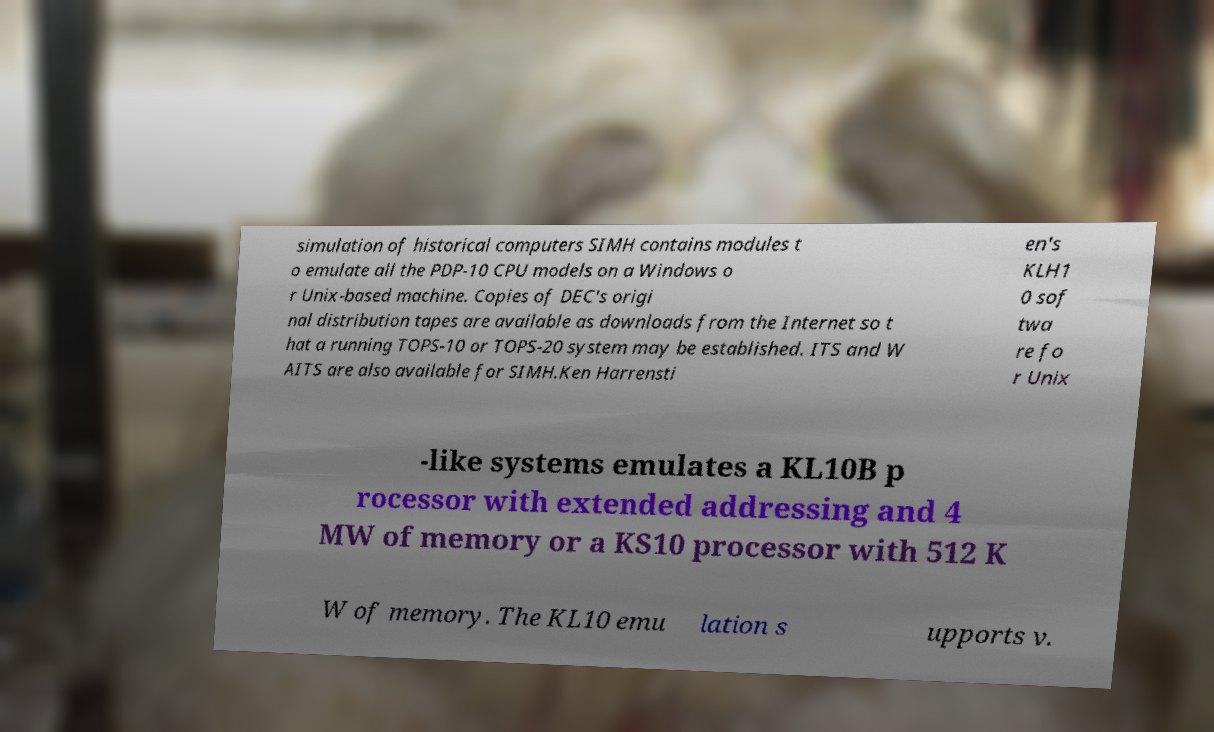Can you accurately transcribe the text from the provided image for me? simulation of historical computers SIMH contains modules t o emulate all the PDP-10 CPU models on a Windows o r Unix-based machine. Copies of DEC's origi nal distribution tapes are available as downloads from the Internet so t hat a running TOPS-10 or TOPS-20 system may be established. ITS and W AITS are also available for SIMH.Ken Harrensti en's KLH1 0 sof twa re fo r Unix -like systems emulates a KL10B p rocessor with extended addressing and 4 MW of memory or a KS10 processor with 512 K W of memory. The KL10 emu lation s upports v. 